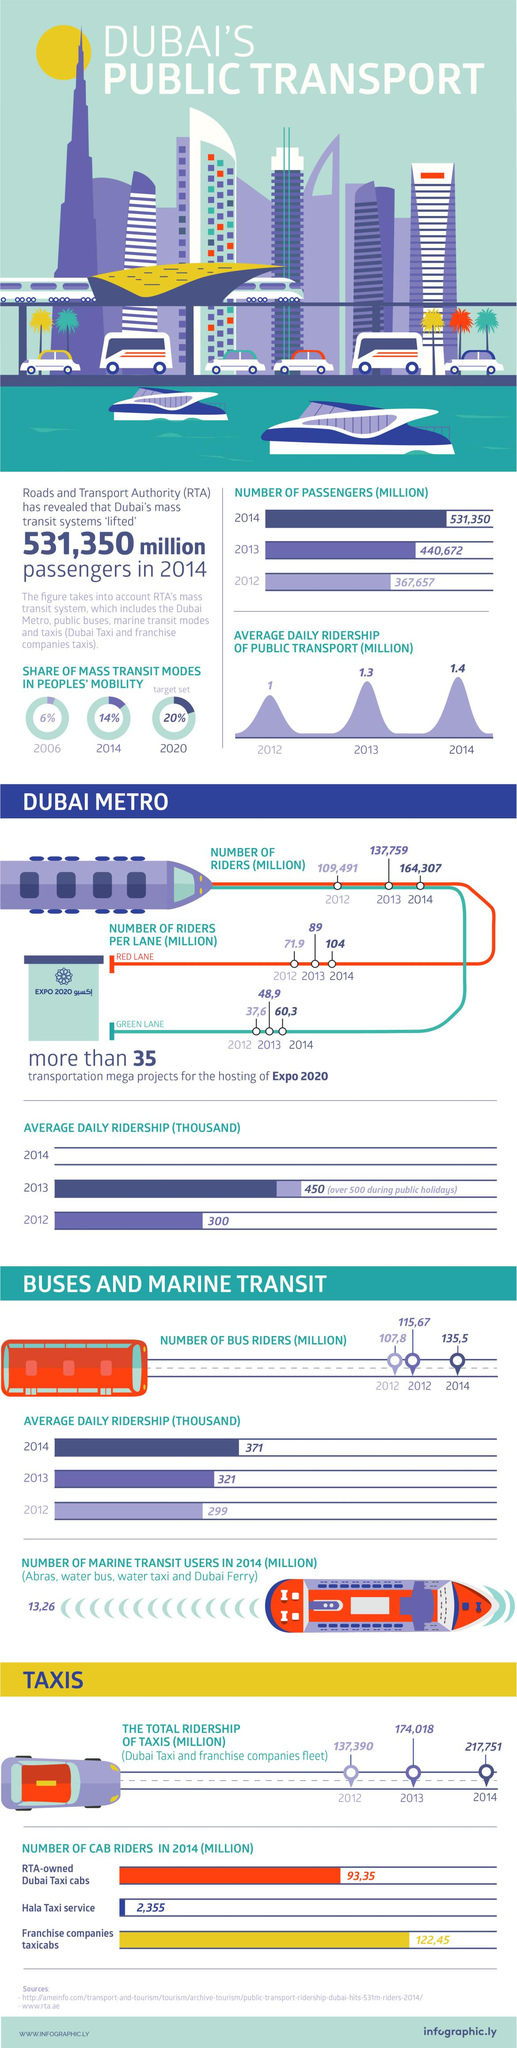Give some essential details in this illustration. In 2012, the average daily ridership of public transport in Dubai was approximately 1 million. In the year 2013, the total ridership of taxis in Dubai was 174,018 individuals. In the year 2013, there were approximately 89 million riders per red lane on the Dubai metro. In the year 2014, the percentage share of mass transit modes in people's mobility in Dubai was found to be 14%. The Dubai Metro offers two available lanes, the RED LANE and the GREEN LANE, which provide efficient transportation services to passengers. 